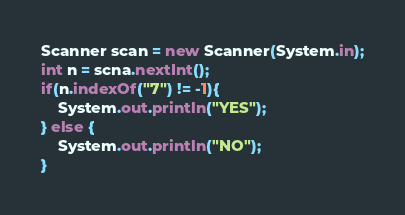Convert code to text. <code><loc_0><loc_0><loc_500><loc_500><_Java_>Scanner scan = new Scanner(System.in);
int n = scna.nextInt();
if(n.indexOf("7") != -1){
	System.out.println("YES");
} else {
	System.out.println("NO");
}</code> 